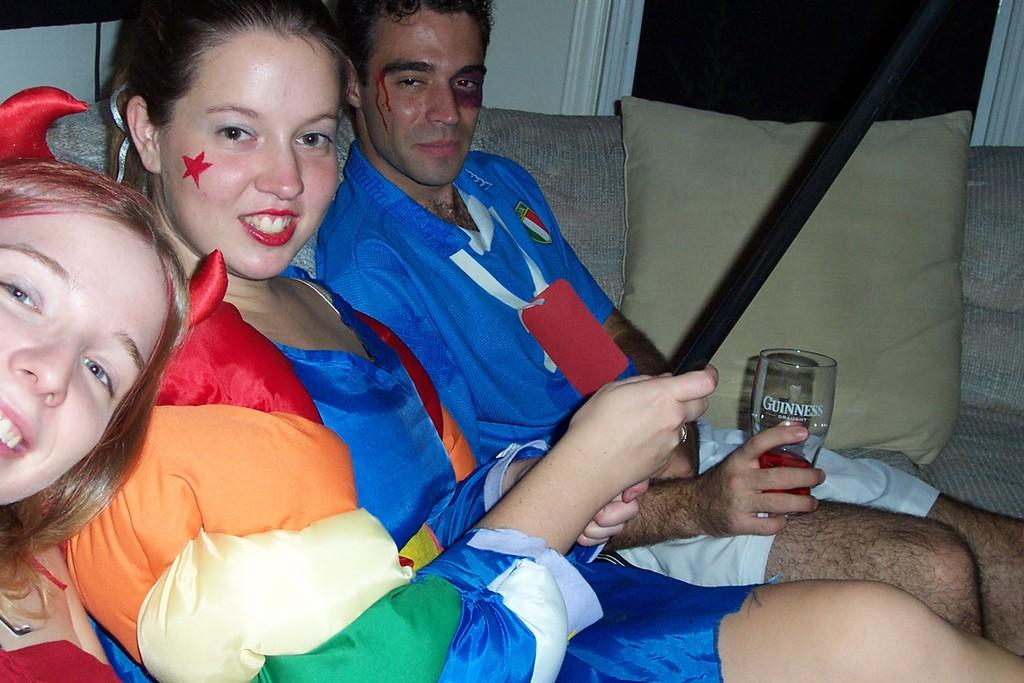Provide a one-sentence caption for the provided image. Two women and a man in costumes and the man is holding a Guinness glass. 